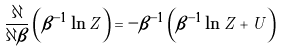Convert formula to latex. <formula><loc_0><loc_0><loc_500><loc_500>\frac { \partial } { \partial \beta } \left ( \beta ^ { - 1 } \ln Z \right ) = - \beta ^ { - 1 } \left ( \beta ^ { - 1 } \ln Z + U \right )</formula> 